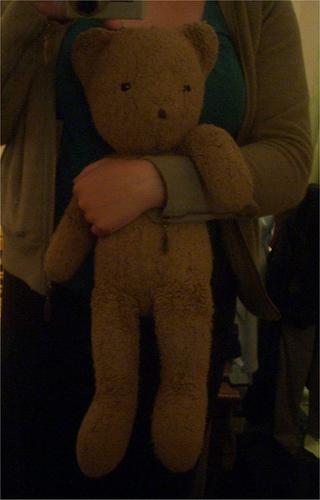What is missing from the bear's head that teddy bears normally have?
Concise answer only. Mouth. Is this teddy bear old?
Short answer required. Yes. Which of the teddy bear's hands is on top?
Concise answer only. Left. Is this a normal sized teddy bear?
Concise answer only. Yes. How many people are in the picture?
Concise answer only. 1. Is it day or night?
Be succinct. Night. What color is the bear?
Short answer required. Brown. What is the person holding in their hand?
Write a very short answer. Teddy bear. Why are the teddy bear's eyes glowing?
Concise answer only. Reflection. What is the dolls eyes?
Answer briefly. Black. Is the bear's hat protecting him from the cold?
Answer briefly. No. Where are the bears?
Be succinct. Arm. How is the bear traveling?
Give a very brief answer. Carried. Is the bear naked?
Write a very short answer. Yes. What is the toy leaning against?
Write a very short answer. Person. Does one of the bears look surprised?
Short answer required. No. Is the person wearing a sweater?
Write a very short answer. Yes. What is the stuffed animal on?
Quick response, please. Person. Can you see trees in the picture?
Answer briefly. No. Where is the green sweater?
Answer briefly. On woman. 